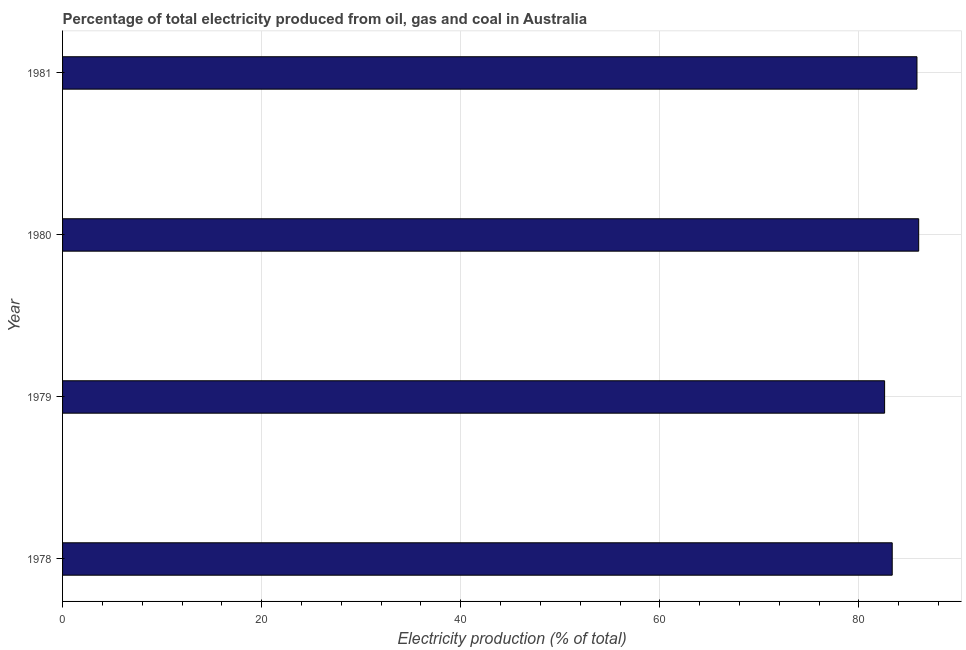What is the title of the graph?
Your response must be concise. Percentage of total electricity produced from oil, gas and coal in Australia. What is the label or title of the X-axis?
Make the answer very short. Electricity production (% of total). What is the label or title of the Y-axis?
Ensure brevity in your answer.  Year. What is the electricity production in 1981?
Give a very brief answer. 85.83. Across all years, what is the maximum electricity production?
Offer a very short reply. 86.01. Across all years, what is the minimum electricity production?
Keep it short and to the point. 82.58. In which year was the electricity production minimum?
Your answer should be compact. 1979. What is the sum of the electricity production?
Provide a short and direct response. 337.77. What is the difference between the electricity production in 1978 and 1981?
Make the answer very short. -2.48. What is the average electricity production per year?
Provide a succinct answer. 84.44. What is the median electricity production?
Keep it short and to the point. 84.59. Do a majority of the years between 1980 and 1978 (inclusive) have electricity production greater than 16 %?
Make the answer very short. Yes. Is the electricity production in 1979 less than that in 1981?
Your answer should be compact. Yes. What is the difference between the highest and the second highest electricity production?
Your answer should be very brief. 0.17. Is the sum of the electricity production in 1978 and 1980 greater than the maximum electricity production across all years?
Provide a short and direct response. Yes. What is the difference between the highest and the lowest electricity production?
Your answer should be compact. 3.42. Are all the bars in the graph horizontal?
Provide a short and direct response. Yes. Are the values on the major ticks of X-axis written in scientific E-notation?
Keep it short and to the point. No. What is the Electricity production (% of total) of 1978?
Ensure brevity in your answer.  83.35. What is the Electricity production (% of total) of 1979?
Keep it short and to the point. 82.58. What is the Electricity production (% of total) in 1980?
Offer a terse response. 86.01. What is the Electricity production (% of total) in 1981?
Your answer should be very brief. 85.83. What is the difference between the Electricity production (% of total) in 1978 and 1979?
Your answer should be very brief. 0.76. What is the difference between the Electricity production (% of total) in 1978 and 1980?
Give a very brief answer. -2.66. What is the difference between the Electricity production (% of total) in 1978 and 1981?
Ensure brevity in your answer.  -2.49. What is the difference between the Electricity production (% of total) in 1979 and 1980?
Provide a short and direct response. -3.42. What is the difference between the Electricity production (% of total) in 1979 and 1981?
Provide a succinct answer. -3.25. What is the difference between the Electricity production (% of total) in 1980 and 1981?
Your response must be concise. 0.17. What is the ratio of the Electricity production (% of total) in 1978 to that in 1979?
Ensure brevity in your answer.  1.01. What is the ratio of the Electricity production (% of total) in 1978 to that in 1980?
Provide a short and direct response. 0.97. What is the ratio of the Electricity production (% of total) in 1978 to that in 1981?
Your response must be concise. 0.97. What is the ratio of the Electricity production (% of total) in 1979 to that in 1981?
Your answer should be very brief. 0.96. What is the ratio of the Electricity production (% of total) in 1980 to that in 1981?
Your answer should be very brief. 1. 